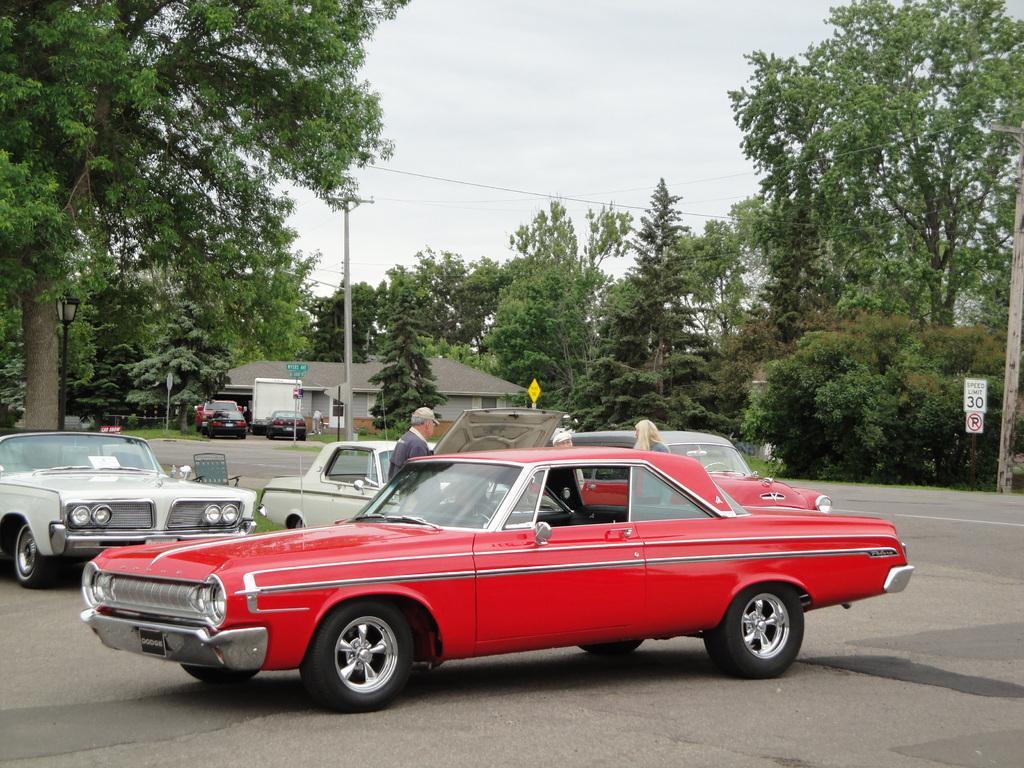In one or two sentences, can you explain what this image depicts? In the picture we can see some vintage cars on the road, they are red and cream in color and behind it, we can see two people are standing, and behind it, we can see some trees and far away from it, we can see some houses and near to it we can see some cars, poles, and behind it also we can see trees and sky. 